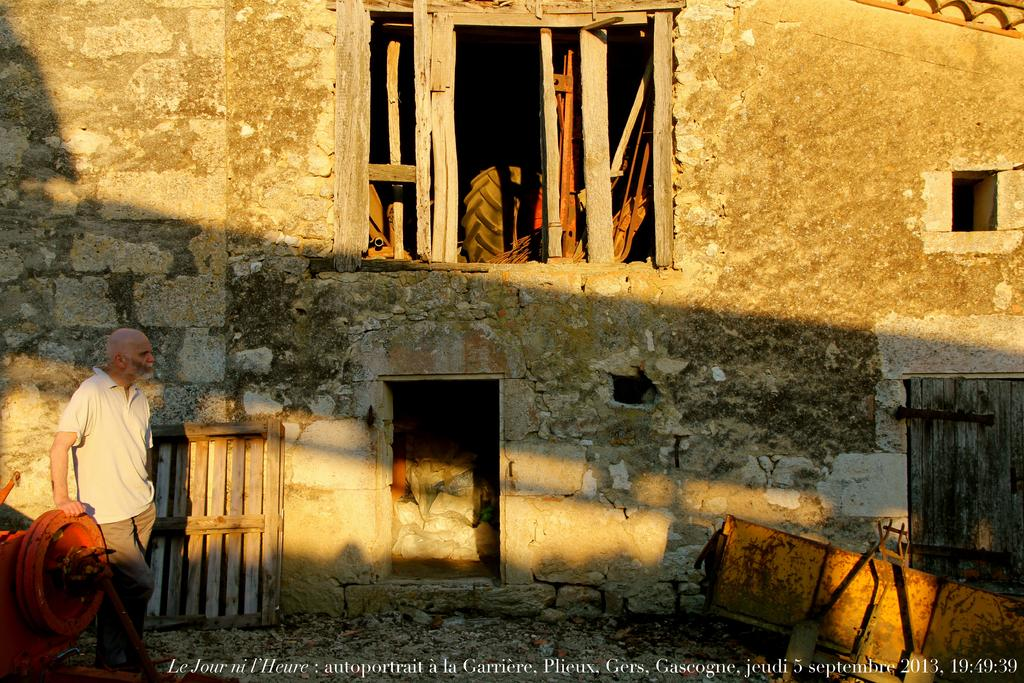Who is present in the image? There is a man in the image. What is behind the man in the image? There is a wall behind the man. What object can be seen in the image? There is a tyre in the image. What type of equipment is visible in the image? There are machinery in the image. Can you describe any additional features of the image? There is a watermark at the bottom of the image. Where is the lunchroom located in the image? There is no lunchroom present in the image. What type of magic is being performed by the man in the image? There is no magic or magician present in the image; it features a man, a wall, a tyre, machinery, and a watermark. 